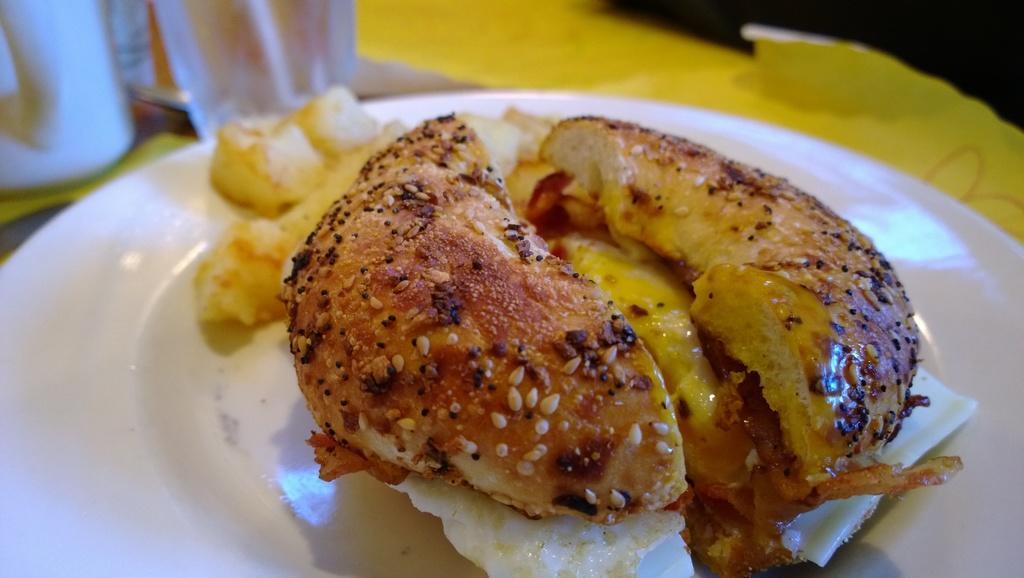How would you summarize this image in a sentence or two? In this picture we can see food in a plate. 